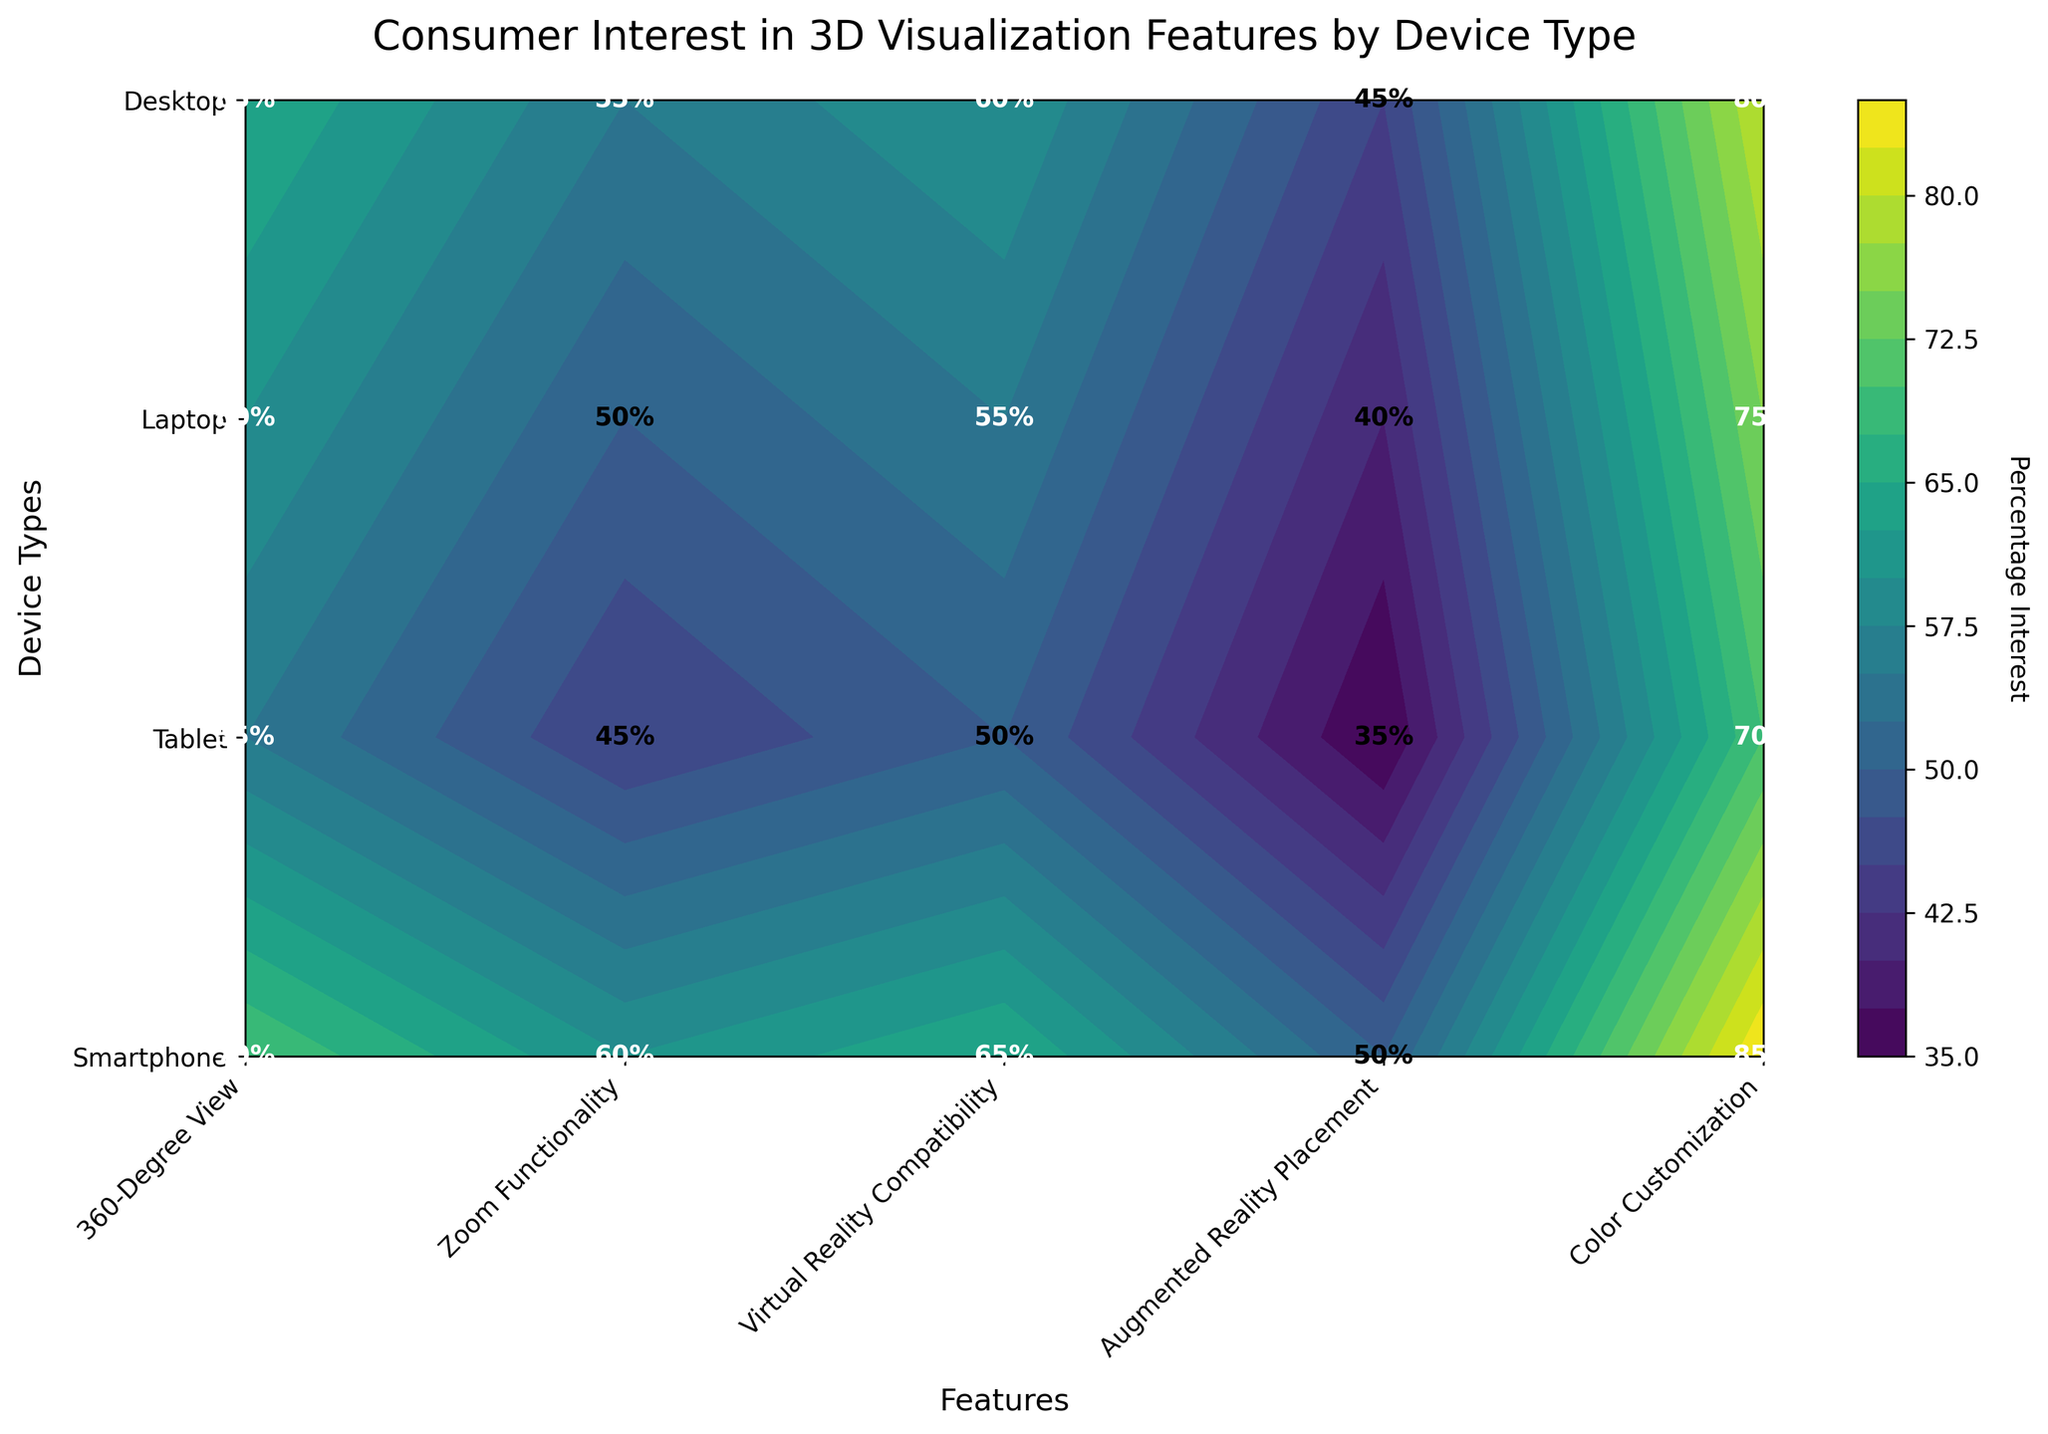What is the title of the figure? The title of the figure is displayed at the top and should provide a summary of what the plot represents.
Answer: Consumer Interest in 3D Visualization Features by Device Type Which device type shows the highest consumer interest in Zoom Functionality? To find the highest consumer interest, locate the cell corresponding to Zoom Functionality for each device type and compare the numbers.
Answer: Desktop What is the average percentage interest in Virtual Reality Compatibility across all device types? Sum the percentage interests in Virtual Reality Compatibility for all device types and then divide by the number of device types (4). The numbers are 40, 45, 35, 50. Calculation: (40 + 45 + 35 + 50) / 4 = 42.5
Answer: 42.5 Which feature has the lowest consumer interest on smartphones? Locate the column for Smartphones and find the feature with the lowest percentage label.
Answer: Virtual Reality Compatibility By how much is consumer interest in Color Customization on desktops greater than that on laptops? Find the percentage of interest in Color Customization for desktops and laptops and subtract the smaller number from the larger one. The values are 65 for Desktop and 50 for Laptop. Calculation: 65 - 50 = 15
Answer: 15 Which device type has the greatest overall interest in Augmented Reality Placement and what is the interest percentage? Find the highest percentage value in the Augmented Reality Placement column and note the corresponding device type.
Answer: Desktop, 60% Is consumer interest higher for Augmented Reality Placement or Virtual Reality Compatibility on tablets? Compare the percentages of interest in Augmented Reality Placement and Virtual Reality Compatibility for tablets. The values are 55 and 45.
Answer: Augmented Reality Placement What is the range of consumer interest percentages for the Zoom Functionality feature across all device types? The range is calculated by subtracting the minimum percentage for Zoom Functionality from the maximum percentage. The numbers are 70 (Laptop) and 85 (Desktop). Calculation: 85 - 70 = 15
Answer: 15 What does the color bar on the side of the contour plot represent? The color bar explains the color-coding used in the contour plot, with shades indicating different levels of percentage interest.
Answer: Percentage Interest 